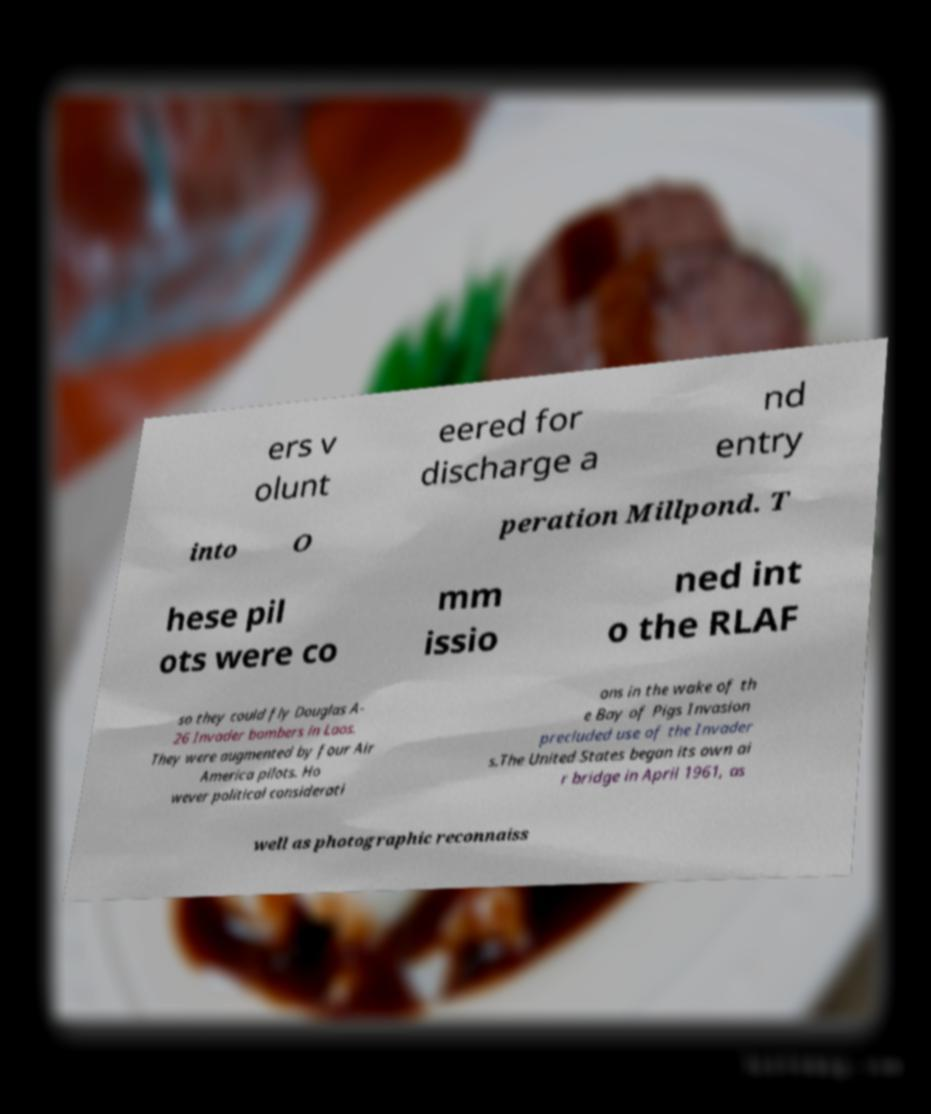Please identify and transcribe the text found in this image. ers v olunt eered for discharge a nd entry into O peration Millpond. T hese pil ots were co mm issio ned int o the RLAF so they could fly Douglas A- 26 Invader bombers in Laos. They were augmented by four Air America pilots. Ho wever political considerati ons in the wake of th e Bay of Pigs Invasion precluded use of the Invader s.The United States began its own ai r bridge in April 1961, as well as photographic reconnaiss 